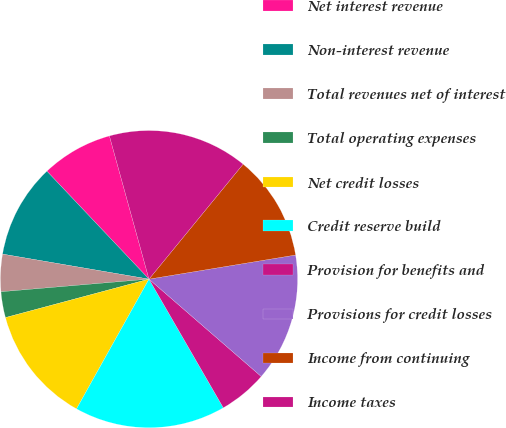Convert chart. <chart><loc_0><loc_0><loc_500><loc_500><pie_chart><fcel>Net interest revenue<fcel>Non-interest revenue<fcel>Total revenues net of interest<fcel>Total operating expenses<fcel>Net credit losses<fcel>Credit reserve build<fcel>Provision for benefits and<fcel>Provisions for credit losses<fcel>Income from continuing<fcel>Income taxes<nl><fcel>7.77%<fcel>10.25%<fcel>4.05%<fcel>2.81%<fcel>12.73%<fcel>16.45%<fcel>5.29%<fcel>13.97%<fcel>11.49%<fcel>15.21%<nl></chart> 